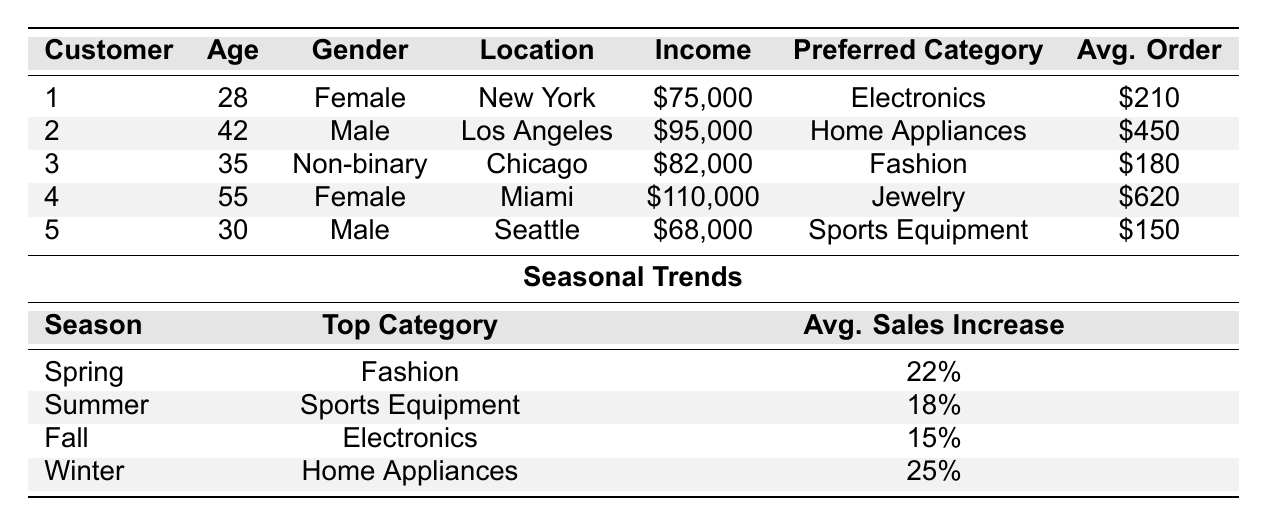What is the total income of all customers in the table? To find the total income, add the individual incomes of all customers: 75000 + 95000 + 82000 + 110000 + 68000 = 437000.
Answer: 437000 Which gender has the highest average order value? Calculate the average order value for each gender: Female (210 + 620) / 2 = 415, Male (450 + 150) / 2 = 300, Non-binary (180) = 180. The highest average is 415 for Female.
Answer: Female How many customers prefer Fashion as their category? There are two customers listed in the table that prefer Fashion (Customer 3).
Answer: 1 What is the average purchase frequency of all customers? Add all purchase frequencies: 3.2 + 2.5 + 4.7 + 1.8 + 3.9 = 16.1. There are 5 customers, so average frequency is 16.1 / 5 = 3.22.
Answer: 3.22 Is there a customer from Miami in the table? Check the location column in the table; there is one customer in Miami (Customer 4).
Answer: Yes Which product category has the highest average sales increase during Winter? Look at the seasonal trends section; it states Home Appliances has a 25% average sales increase in Winter, which is the highest.
Answer: Home Appliances What is the average order value for customers in New York and Miami? Customer 1 (New York) has an average order value of 210, and Customer 4 (Miami) has 620. Their average is (210 + 620) / 2 = 415.
Answer: 415 In which season does Fashion become the top category? Check the seasonal trends; Fashion is the top category in Spring.
Answer: Spring Who has the lowest income among the customers? Compare the income values of all customers: 75000 (Customer 1), 95000 (Customer 2), 82000 (Customer 3), 110000 (Customer 4), and 68000 (Customer 5). The lowest is 68000 (Customer 5).
Answer: Customer 5 What percentage increase in sales is observed in Summer for Sports Equipment? Refer to the seasonal trends; Summer shows an average sales increase of 18%.
Answer: 18% 